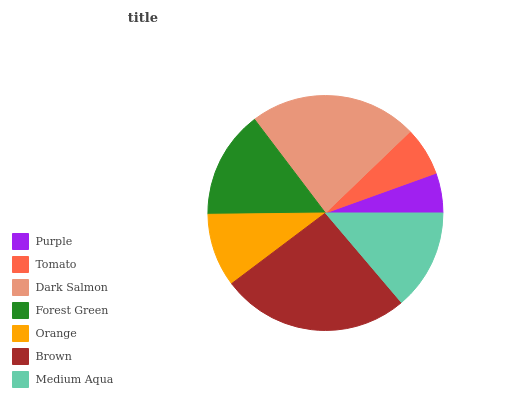Is Purple the minimum?
Answer yes or no. Yes. Is Brown the maximum?
Answer yes or no. Yes. Is Tomato the minimum?
Answer yes or no. No. Is Tomato the maximum?
Answer yes or no. No. Is Tomato greater than Purple?
Answer yes or no. Yes. Is Purple less than Tomato?
Answer yes or no. Yes. Is Purple greater than Tomato?
Answer yes or no. No. Is Tomato less than Purple?
Answer yes or no. No. Is Medium Aqua the high median?
Answer yes or no. Yes. Is Medium Aqua the low median?
Answer yes or no. Yes. Is Purple the high median?
Answer yes or no. No. Is Tomato the low median?
Answer yes or no. No. 